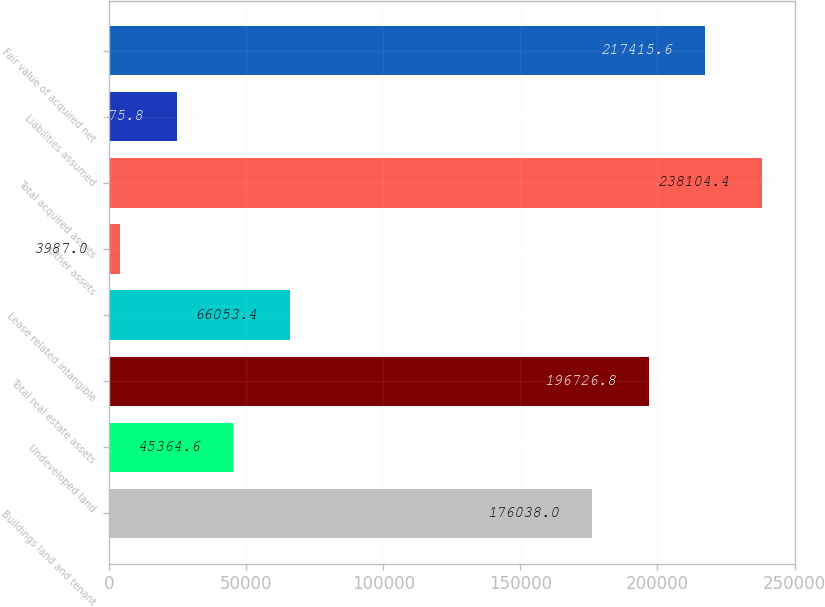Convert chart. <chart><loc_0><loc_0><loc_500><loc_500><bar_chart><fcel>Buildings land and tenant<fcel>Undeveloped land<fcel>Total real estate assets<fcel>Lease related intangible<fcel>Other assets<fcel>Total acquired assets<fcel>Liabilities assumed<fcel>Fair value of acquired net<nl><fcel>176038<fcel>45364.6<fcel>196727<fcel>66053.4<fcel>3987<fcel>238104<fcel>24675.8<fcel>217416<nl></chart> 